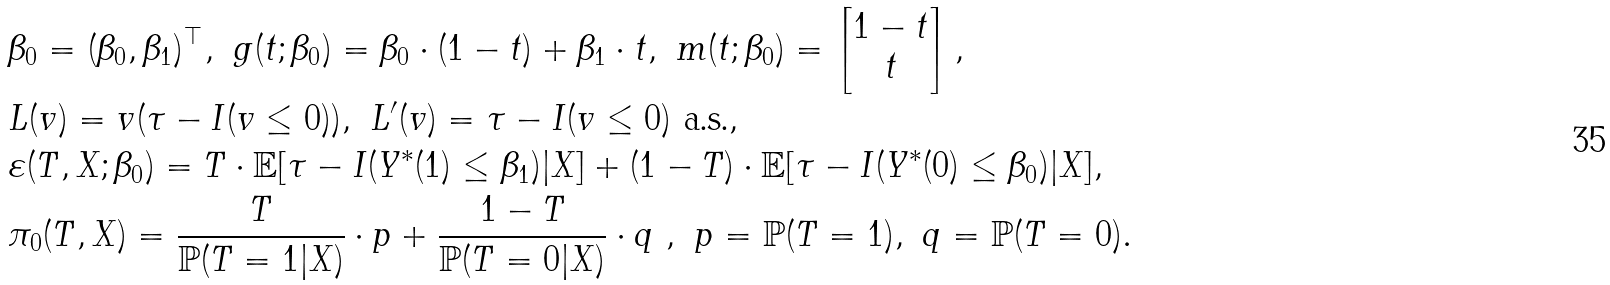Convert formula to latex. <formula><loc_0><loc_0><loc_500><loc_500>& \beta _ { 0 } = ( \beta _ { 0 } , \beta _ { 1 } ) ^ { \top } , \ g ( t ; \beta _ { 0 } ) = \beta _ { 0 } \cdot ( 1 - t ) + \beta _ { 1 } \cdot t , \ m ( t ; \beta _ { 0 } ) = \begin{bmatrix} 1 - t \\ t \end{bmatrix} , \\ & L ( v ) = v ( \tau - I ( v \leq 0 ) ) , \ L ^ { \prime } ( v ) = \tau - I ( v \leq 0 ) \ \text {a.s.} , \\ & \varepsilon ( T , X ; \beta _ { 0 } ) = T \cdot \mathbb { E } [ \tau - I ( Y ^ { * } ( 1 ) \leq \beta _ { 1 } ) | X ] + ( 1 - T ) \cdot \mathbb { E } [ \tau - I ( Y ^ { * } ( 0 ) \leq \beta _ { 0 } ) | X ] , \\ & \pi _ { 0 } ( T , X ) = \frac { T } { \mathbb { P } ( T = 1 | X ) } \cdot p + \frac { 1 - T } { \mathbb { P } ( T = 0 | X ) } \cdot q \ , \ p = \mathbb { P } ( T = 1 ) , \ q = \mathbb { P } ( T = 0 ) .</formula> 